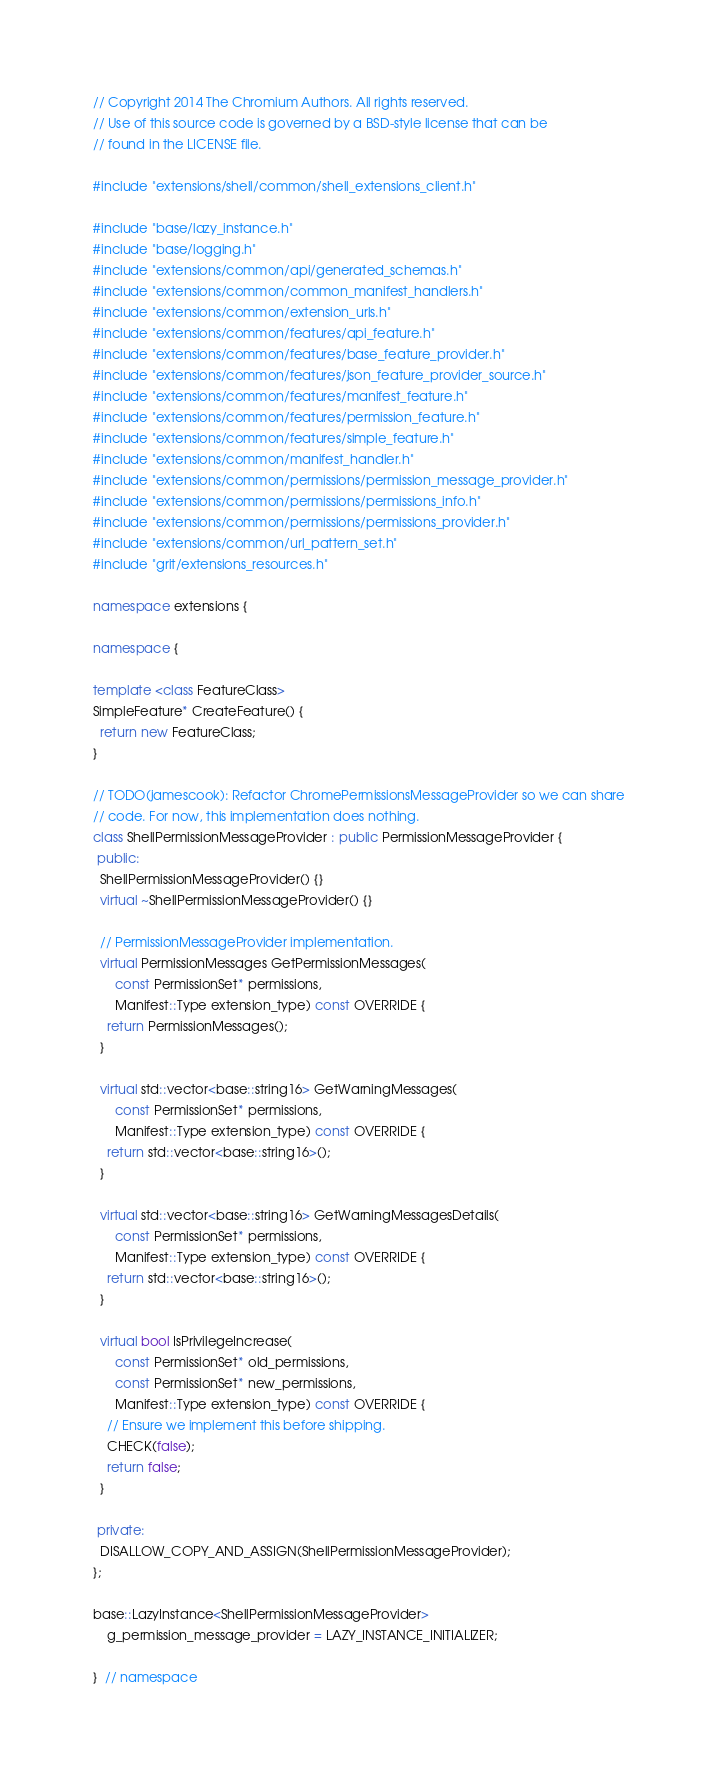Convert code to text. <code><loc_0><loc_0><loc_500><loc_500><_C++_>// Copyright 2014 The Chromium Authors. All rights reserved.
// Use of this source code is governed by a BSD-style license that can be
// found in the LICENSE file.

#include "extensions/shell/common/shell_extensions_client.h"

#include "base/lazy_instance.h"
#include "base/logging.h"
#include "extensions/common/api/generated_schemas.h"
#include "extensions/common/common_manifest_handlers.h"
#include "extensions/common/extension_urls.h"
#include "extensions/common/features/api_feature.h"
#include "extensions/common/features/base_feature_provider.h"
#include "extensions/common/features/json_feature_provider_source.h"
#include "extensions/common/features/manifest_feature.h"
#include "extensions/common/features/permission_feature.h"
#include "extensions/common/features/simple_feature.h"
#include "extensions/common/manifest_handler.h"
#include "extensions/common/permissions/permission_message_provider.h"
#include "extensions/common/permissions/permissions_info.h"
#include "extensions/common/permissions/permissions_provider.h"
#include "extensions/common/url_pattern_set.h"
#include "grit/extensions_resources.h"

namespace extensions {

namespace {

template <class FeatureClass>
SimpleFeature* CreateFeature() {
  return new FeatureClass;
}

// TODO(jamescook): Refactor ChromePermissionsMessageProvider so we can share
// code. For now, this implementation does nothing.
class ShellPermissionMessageProvider : public PermissionMessageProvider {
 public:
  ShellPermissionMessageProvider() {}
  virtual ~ShellPermissionMessageProvider() {}

  // PermissionMessageProvider implementation.
  virtual PermissionMessages GetPermissionMessages(
      const PermissionSet* permissions,
      Manifest::Type extension_type) const OVERRIDE {
    return PermissionMessages();
  }

  virtual std::vector<base::string16> GetWarningMessages(
      const PermissionSet* permissions,
      Manifest::Type extension_type) const OVERRIDE {
    return std::vector<base::string16>();
  }

  virtual std::vector<base::string16> GetWarningMessagesDetails(
      const PermissionSet* permissions,
      Manifest::Type extension_type) const OVERRIDE {
    return std::vector<base::string16>();
  }

  virtual bool IsPrivilegeIncrease(
      const PermissionSet* old_permissions,
      const PermissionSet* new_permissions,
      Manifest::Type extension_type) const OVERRIDE {
    // Ensure we implement this before shipping.
    CHECK(false);
    return false;
  }

 private:
  DISALLOW_COPY_AND_ASSIGN(ShellPermissionMessageProvider);
};

base::LazyInstance<ShellPermissionMessageProvider>
    g_permission_message_provider = LAZY_INSTANCE_INITIALIZER;

}  // namespace
</code> 